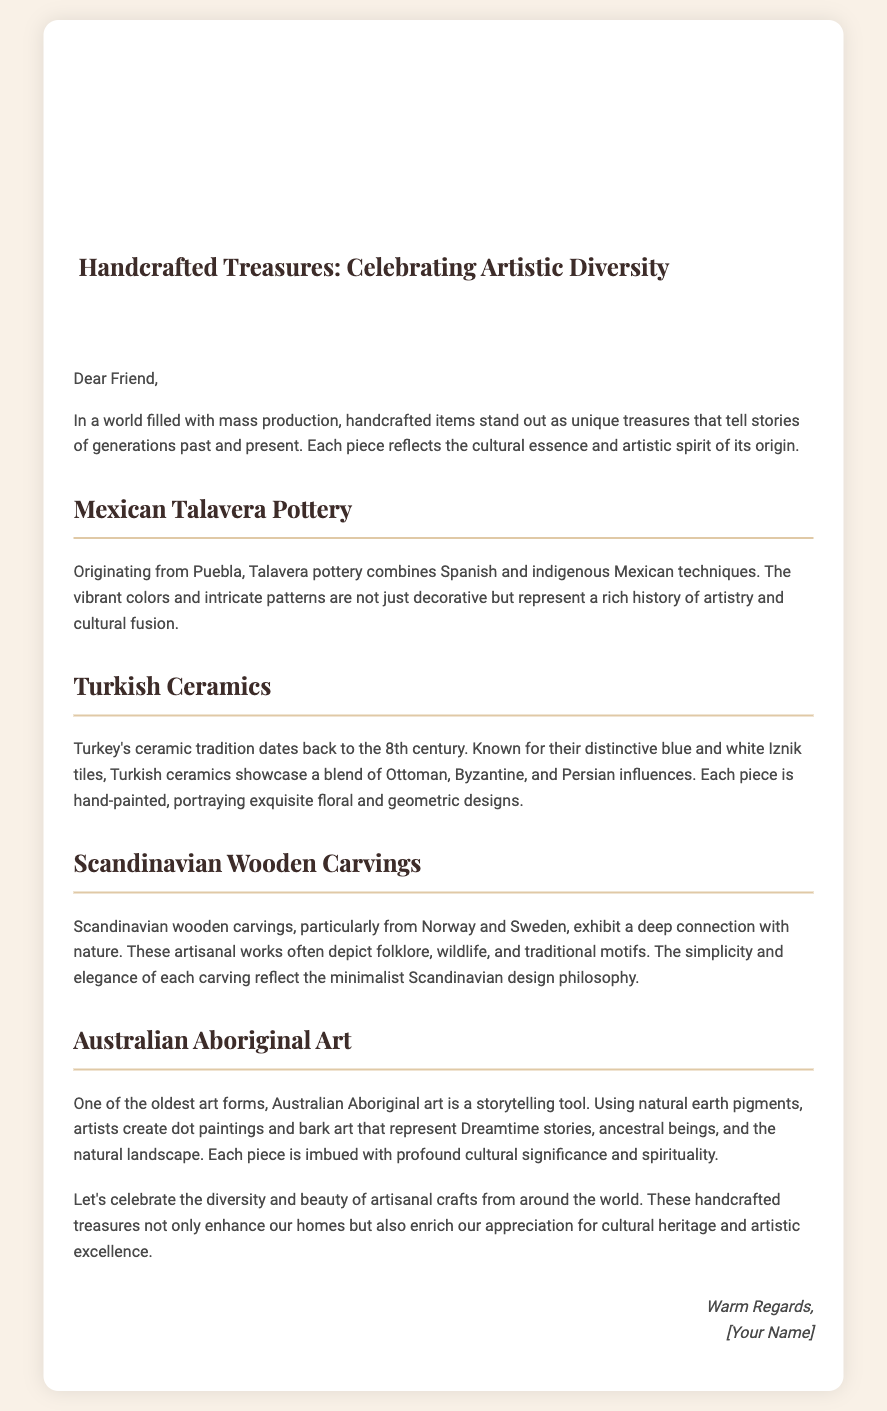What is the title of the card? The title is prominently displayed at the top of the card, indicating the main theme.
Answer: Handcrafted Treasures: Celebrating Artistic Diversity Where does Mexican Talavera pottery originate? The document specifies the geographical origin of this craft, providing cultural context.
Answer: Puebla What is a distinctive feature of Turkish ceramics? This detail articulates a particular style associated with the craft, representing its historical roots.
Answer: Blue and white Iznik tiles Which cultures influenced Turkish ceramics? The document outlines the various cultural impacts on this form of art to highlight its diversity.
Answer: Ottoman, Byzantine, and Persian What do Scandinavian wooden carvings reflect? This question examines the thematic connection between the craft and its cultural philosophy.
Answer: Minimalist Scandinavian design philosophy What type of art is Australian Aboriginal art considered to be? The document describes the purpose and cultural significance of this art form, revealing its social function.
Answer: Storytelling tool How many sections are dedicated to different handcrafted items? This question addresses the structural organization of the document, asking about the sections’ count.
Answer: Four What is the overall message of the card? The document conveys a specific sentiment regarding the value of handcrafted items globally, seeking to summarize its intention.
Answer: Celebrate diversity and beauty of artisanal crafts 